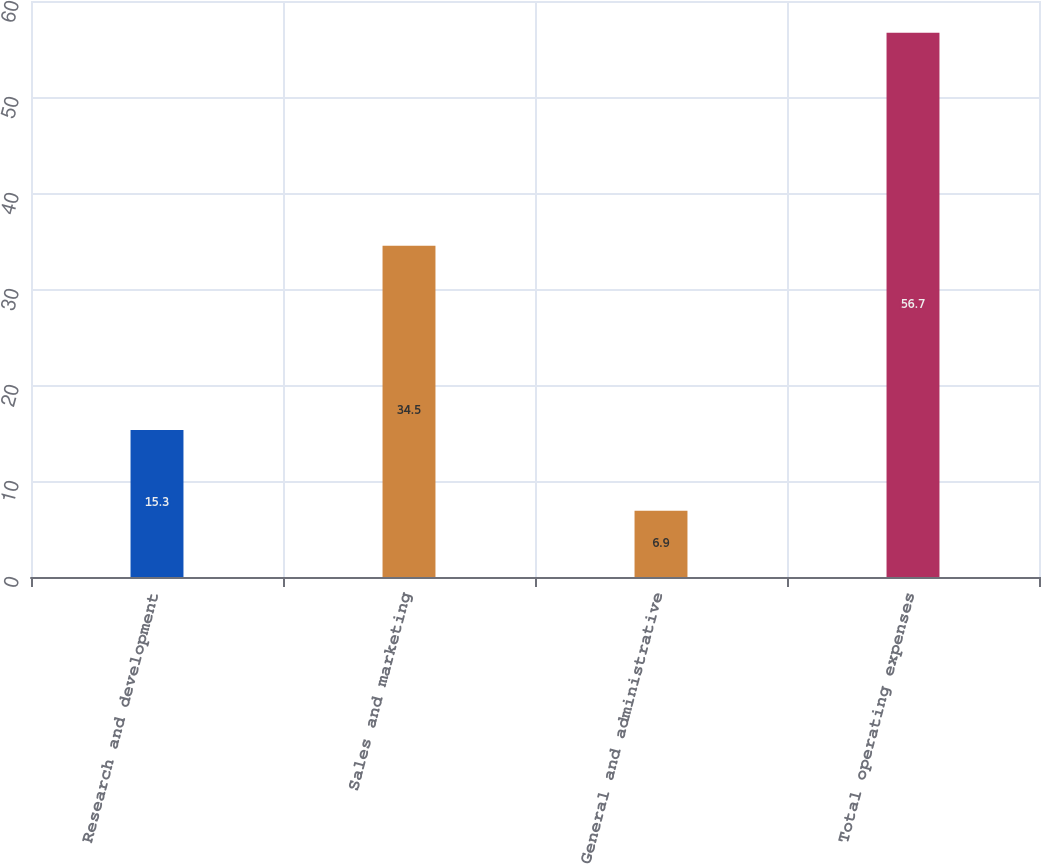Convert chart. <chart><loc_0><loc_0><loc_500><loc_500><bar_chart><fcel>Research and development<fcel>Sales and marketing<fcel>General and administrative<fcel>Total operating expenses<nl><fcel>15.3<fcel>34.5<fcel>6.9<fcel>56.7<nl></chart> 